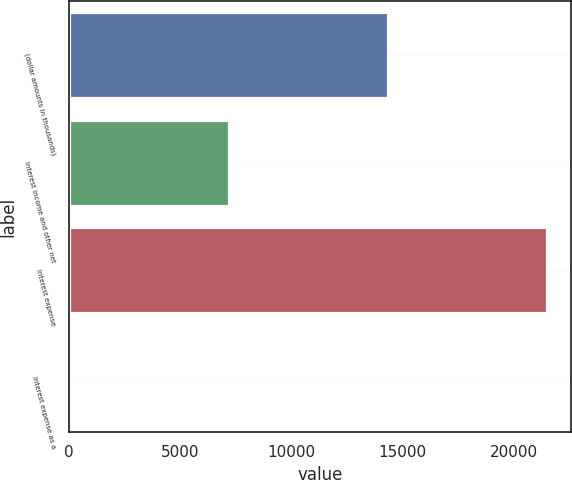Convert chart to OTSL. <chart><loc_0><loc_0><loc_500><loc_500><bar_chart><fcel>(dollar amounts in thousands)<fcel>Interest income and other net<fcel>Interest expense<fcel>Interest expense as a<nl><fcel>14325.5<fcel>7163.04<fcel>21487.9<fcel>0.6<nl></chart> 